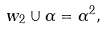<formula> <loc_0><loc_0><loc_500><loc_500>w _ { 2 } \cup \alpha = \alpha ^ { 2 } ,</formula> 